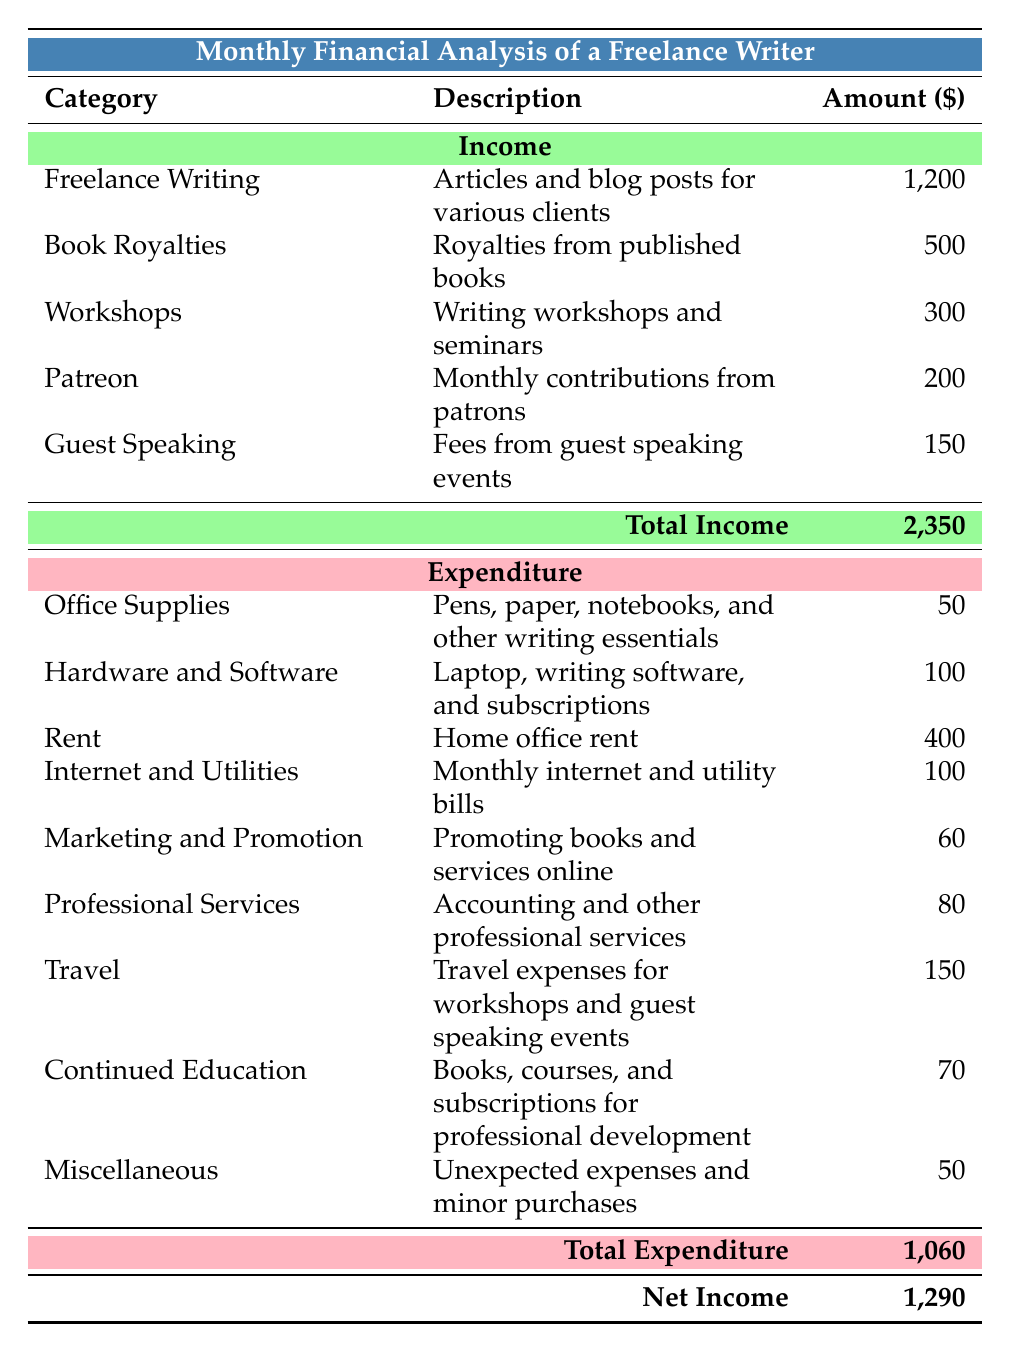What is the total income of the freelance writer? The total income can be found by adding all the income amounts listed in the table: 1200 + 500 + 300 + 200 + 150 = 2350.
Answer: 2350 How much does the freelance writer spend on rent? The rent amount is specifically mentioned in the table under expenditure, which states it is 400.
Answer: 400 Is the amount spent on office supplies greater than the amount spent on internet and utilities? The amount for office supplies is 50 and for internet and utilities is 100. Since 50 is less than 100, the statement is false.
Answer: No What is the total expenditure of the freelance writer? To find the total expenditure, we sum up all the expenditure amounts: 50 + 100 + 400 + 100 + 60 + 80 + 150 + 70 + 50 = 1060.
Answer: 1060 How much more does the freelance writer earn from freelance writing compared to guest speaking? Freelance writing earns 1200, and guest speaking earns 150. The difference is 1200 - 150 = 1050.
Answer: 1050 Does the freelance writer have a net income after expenses? The net income is calculated as total income minus total expenditure: 2350 - 1060 = 1290, which is greater than zero, so the answer is yes.
Answer: Yes What is the percentage of the total income earned from book royalties? The income from book royalties is 500. To find the percentage, we divide it by the total income and multiply by 100: (500 / 2350) * 100 ≈ 21.28%.
Answer: Approximately 21.28% If the freelance writer reduces travel expenses by 30%, what will the new amount spent on travel be? The current amount spent on travel is 150. A 30% reduction means savings of 0.30 * 150 = 45. The new amount will be 150 - 45 = 105.
Answer: 105 What is the total amount spent on professional services and marketing combined? The amount spent on professional services is 80, and marketing is 60. The total is 80 + 60 = 140.
Answer: 140 